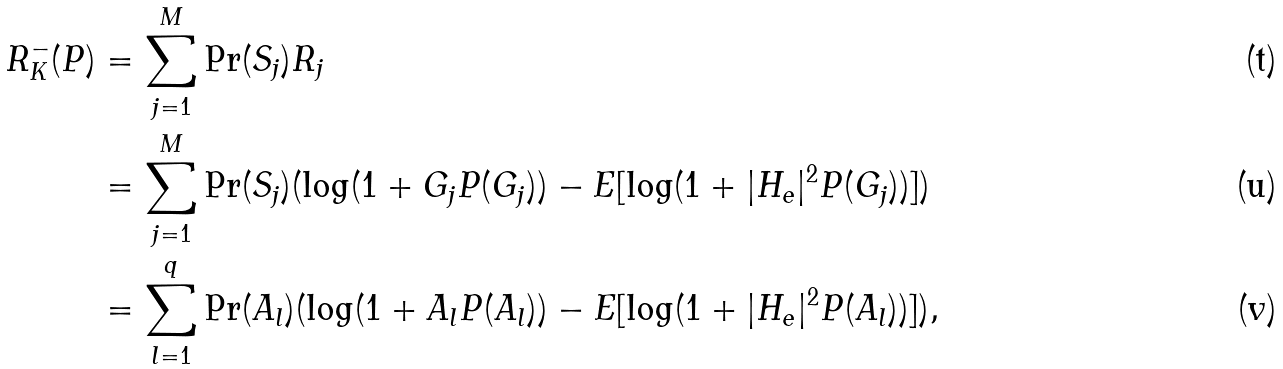Convert formula to latex. <formula><loc_0><loc_0><loc_500><loc_500>R ^ { - } _ { K } ( P ) & = \sum _ { j = 1 } ^ { M } \Pr ( S _ { j } ) R _ { j } \\ & = \sum _ { j = 1 } ^ { M } \Pr ( S _ { j } ) ( \log ( 1 + G _ { j } P ( G _ { j } ) ) - E [ \log ( 1 + | H _ { e } | ^ { 2 } P ( G _ { j } ) ) ] ) \\ & = \sum _ { l = 1 } ^ { q } \Pr ( A _ { l } ) ( \log ( 1 + A _ { l } P ( A _ { l } ) ) - E [ \log ( 1 + | H _ { e } | ^ { 2 } P ( A _ { l } ) ) ] ) ,</formula> 